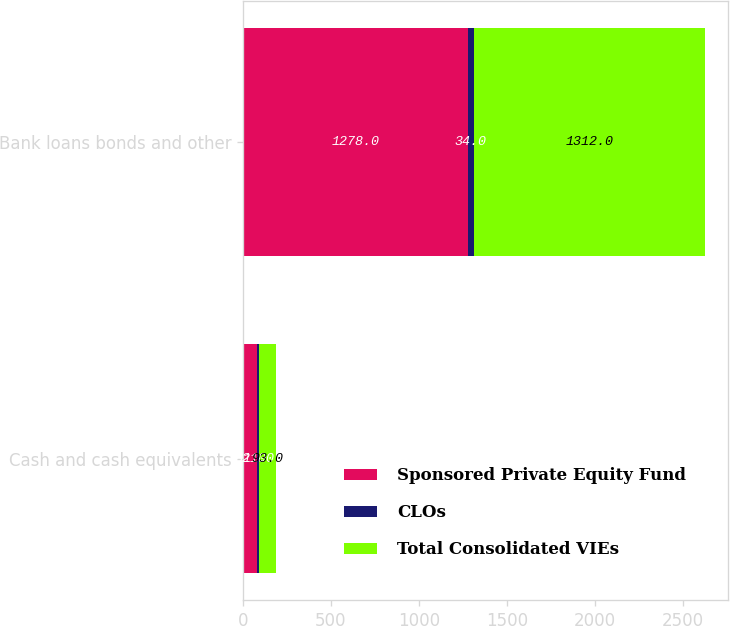Convert chart. <chart><loc_0><loc_0><loc_500><loc_500><stacked_bar_chart><ecel><fcel>Cash and cash equivalents<fcel>Bank loans bonds and other<nl><fcel>Sponsored Private Equity Fund<fcel>82<fcel>1278<nl><fcel>CLOs<fcel>11<fcel>34<nl><fcel>Total Consolidated VIEs<fcel>93<fcel>1312<nl></chart> 